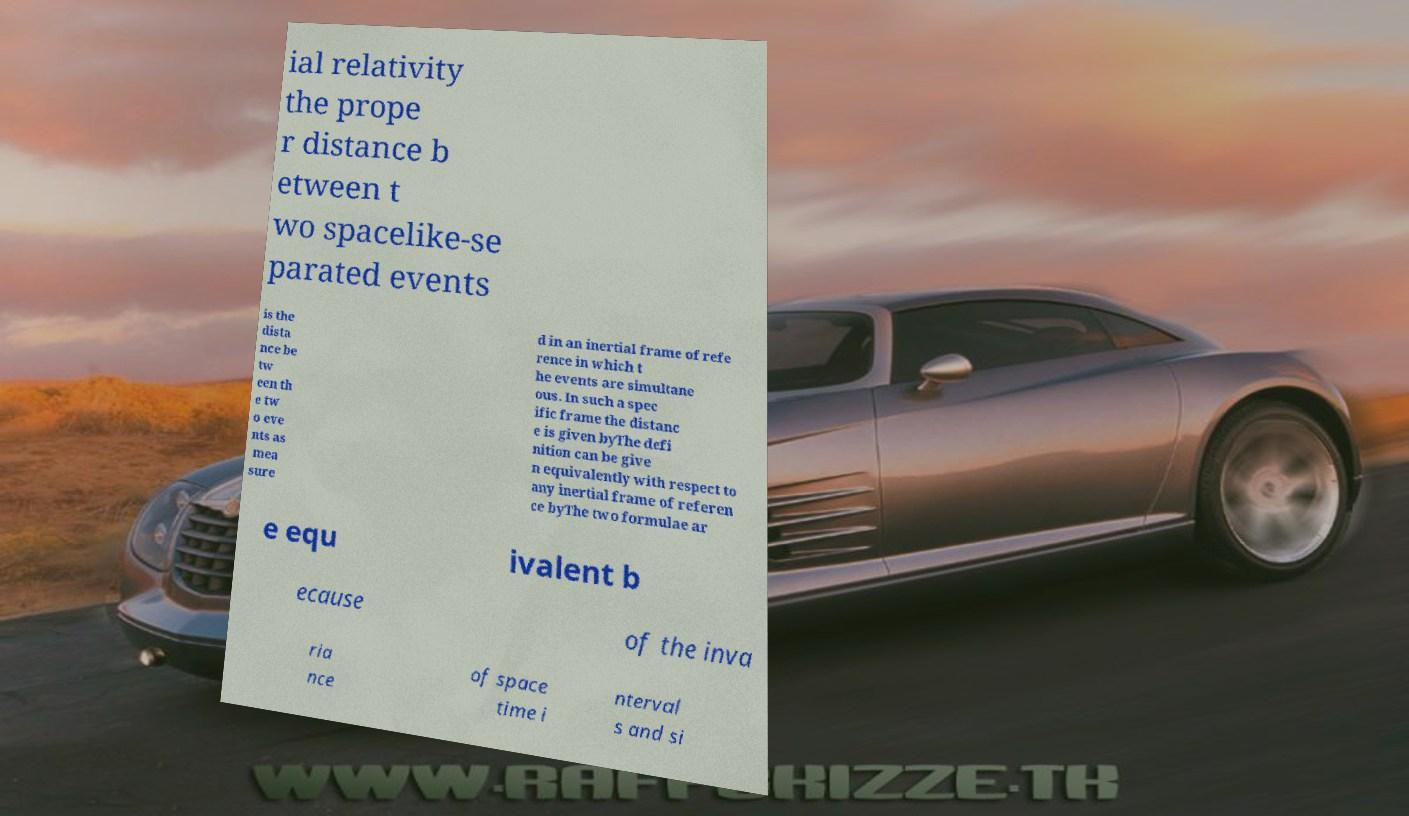Please identify and transcribe the text found in this image. ial relativity the prope r distance b etween t wo spacelike-se parated events is the dista nce be tw een th e tw o eve nts as mea sure d in an inertial frame of refe rence in which t he events are simultane ous. In such a spec ific frame the distanc e is given byThe defi nition can be give n equivalently with respect to any inertial frame of referen ce byThe two formulae ar e equ ivalent b ecause of the inva ria nce of space time i nterval s and si 